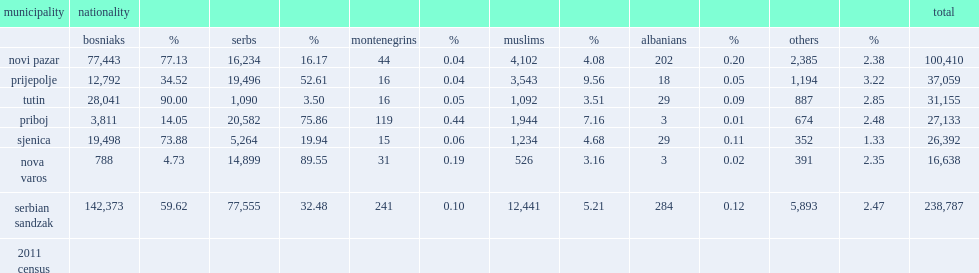What was the population of novi pazar? 100410.0. 